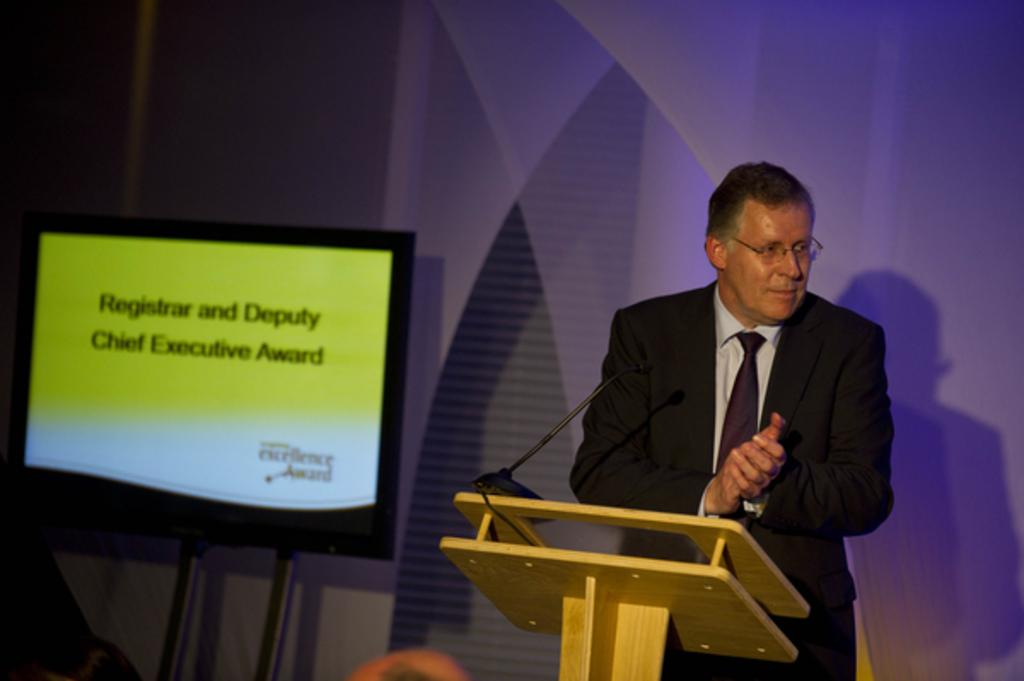What is the person in the image doing? The person is standing in the image. What is the person wearing? The person is wearing a suit. What object is in front of the person? There is a microphone in front of the person. What electronic device is at the side of the person? There is a television at the side of the person. What can be seen behind the person? There is a wall visible in the image. What type of ray is visible in the image? There is no ray present in the image. What industry is the person working in, as indicated by the objects in the image? The objects in the image do not specifically indicate an industry. 